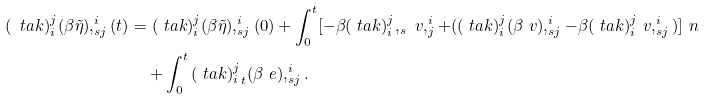Convert formula to latex. <formula><loc_0><loc_0><loc_500><loc_500>( \ t a k ) _ { i } ^ { j } ( \beta \tilde { \eta } ) , _ { s j } ^ { i } ( t ) & = ( \ t a k ) _ { i } ^ { j } ( \beta \tilde { \eta } ) , _ { s j } ^ { i } ( 0 ) + \int _ { 0 } ^ { t } [ - \beta ( \ t a k ) _ { i } ^ { j } , _ { s } \ v , _ { j } ^ { i } + ( ( \ t a k ) _ { i } ^ { j } ( \beta \ v ) , _ { s j } ^ { i } - \beta ( \ t a k ) _ { i } ^ { j } \ v , _ { s j } ^ { i } ) ] \ n \\ & \quad + \int _ { 0 } ^ { t } { ( \ t a k ) _ { i } ^ { j } } _ { t } ( \beta \ e ) , _ { s j } ^ { i } .</formula> 